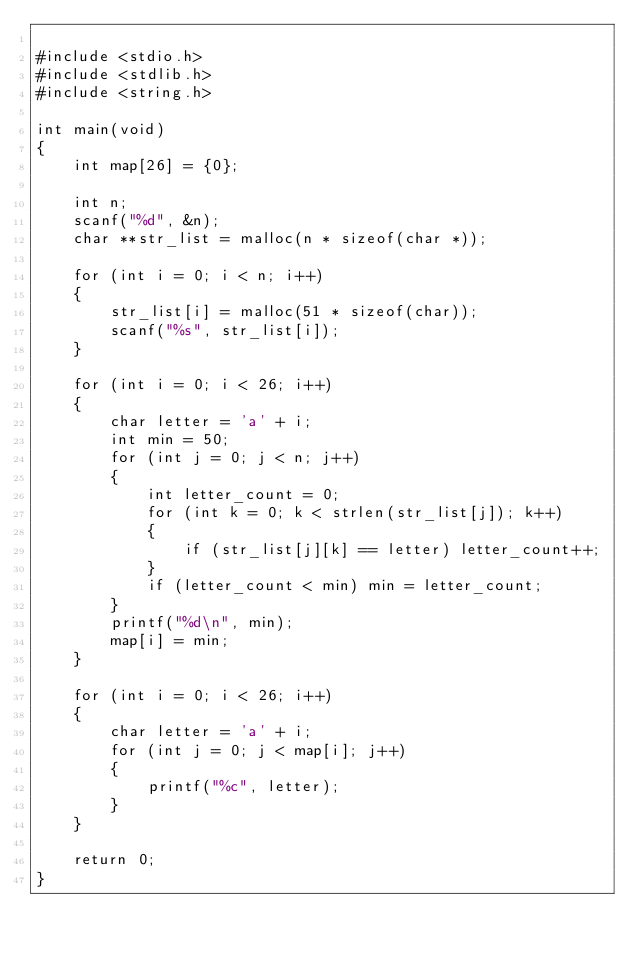Convert code to text. <code><loc_0><loc_0><loc_500><loc_500><_C_>
#include <stdio.h>
#include <stdlib.h>
#include <string.h>

int main(void)
{
    int map[26] = {0};

    int n;
    scanf("%d", &n);
    char **str_list = malloc(n * sizeof(char *));

    for (int i = 0; i < n; i++)
    {
        str_list[i] = malloc(51 * sizeof(char));
        scanf("%s", str_list[i]);
    }

    for (int i = 0; i < 26; i++)
    {
        char letter = 'a' + i;
        int min = 50;
        for (int j = 0; j < n; j++)
        {
            int letter_count = 0;
            for (int k = 0; k < strlen(str_list[j]); k++)
            {
                if (str_list[j][k] == letter) letter_count++;
            }
            if (letter_count < min) min = letter_count;
        }
        printf("%d\n", min);
        map[i] = min;
    }

    for (int i = 0; i < 26; i++)
    {
        char letter = 'a' + i;
        for (int j = 0; j < map[i]; j++)
        {
            printf("%c", letter);
        }
    }

    return 0;
}
</code> 